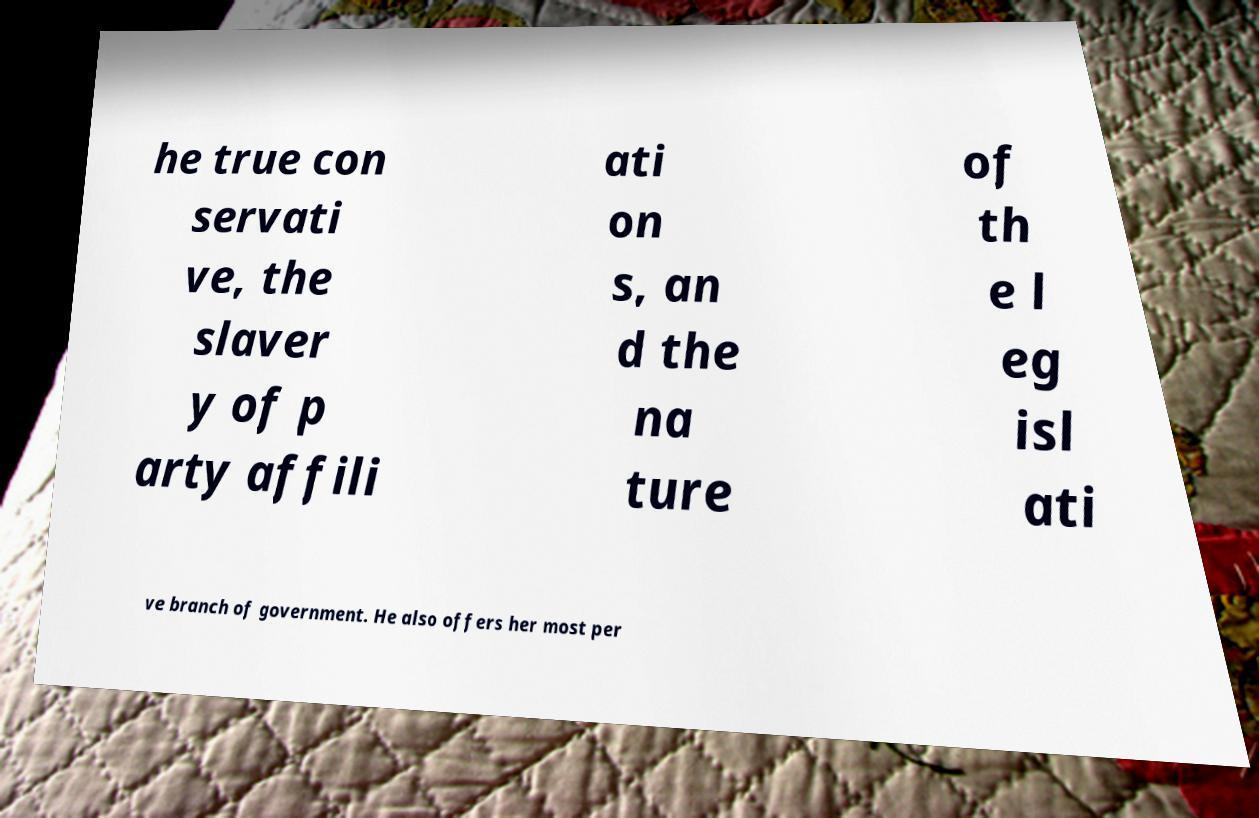Can you accurately transcribe the text from the provided image for me? he true con servati ve, the slaver y of p arty affili ati on s, an d the na ture of th e l eg isl ati ve branch of government. He also offers her most per 